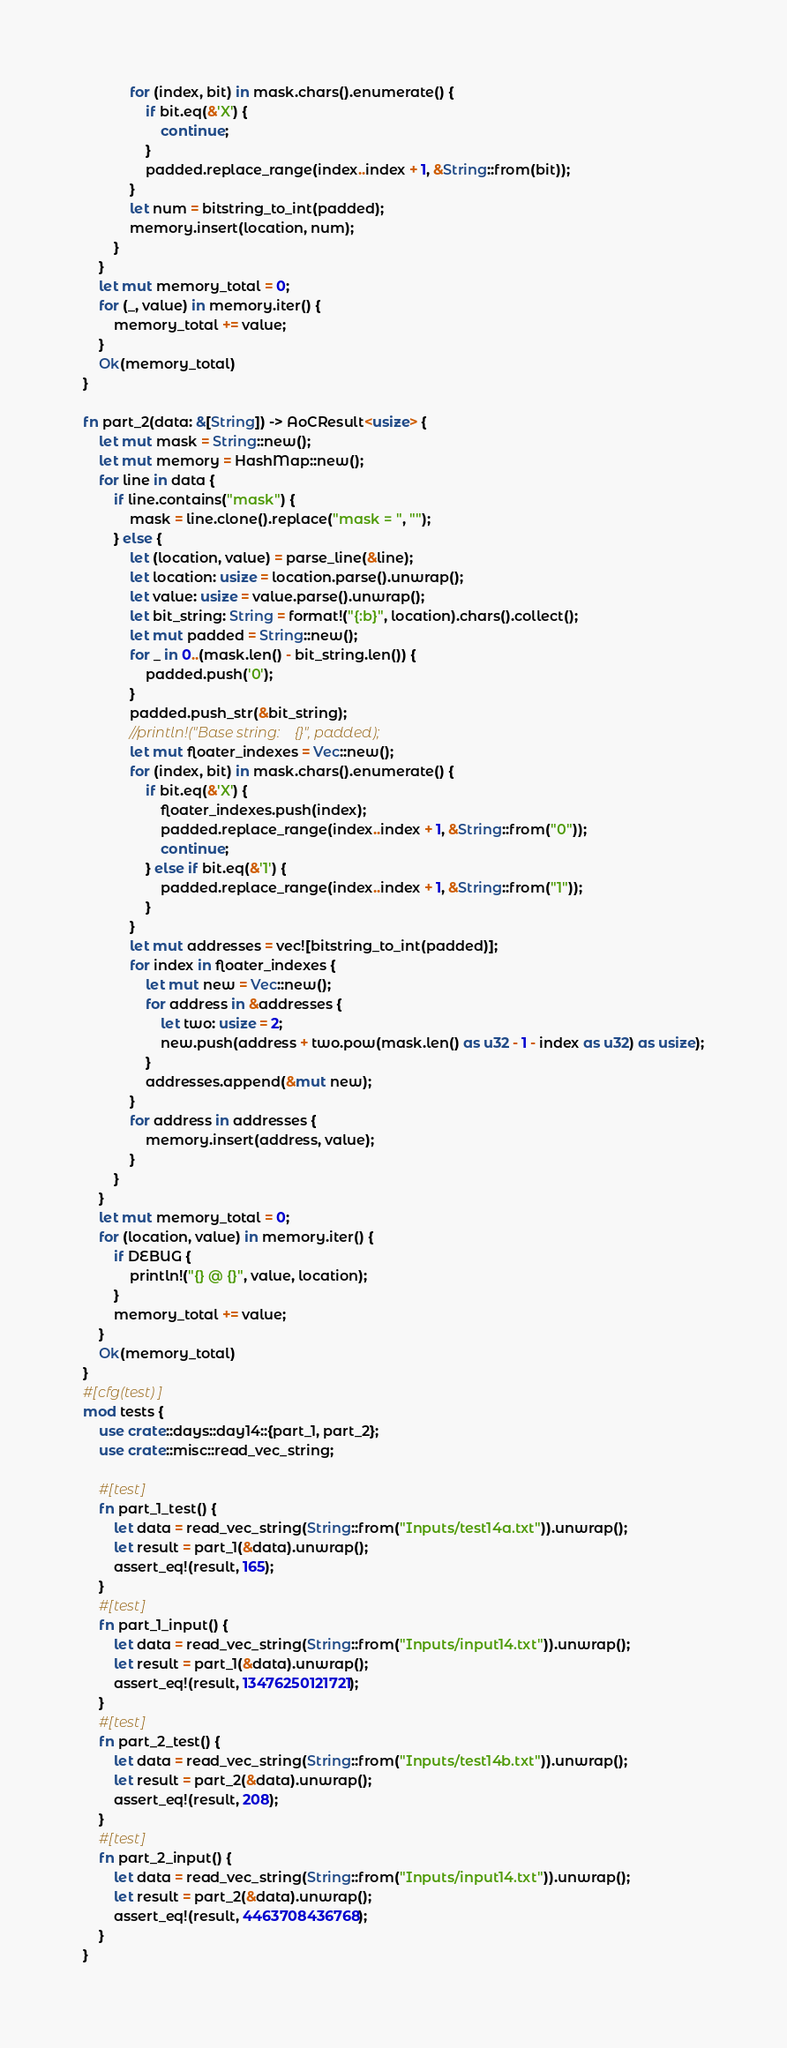<code> <loc_0><loc_0><loc_500><loc_500><_Rust_>            for (index, bit) in mask.chars().enumerate() {
                if bit.eq(&'X') {
                    continue;
                }
                padded.replace_range(index..index + 1, &String::from(bit));
            }
            let num = bitstring_to_int(padded);
            memory.insert(location, num);
        }
    }
    let mut memory_total = 0;
    for (_, value) in memory.iter() {
        memory_total += value;
    }
    Ok(memory_total)
}

fn part_2(data: &[String]) -> AoCResult<usize> {
    let mut mask = String::new();
    let mut memory = HashMap::new();
    for line in data {
        if line.contains("mask") {
            mask = line.clone().replace("mask = ", "");
        } else {
            let (location, value) = parse_line(&line);
            let location: usize = location.parse().unwrap();
            let value: usize = value.parse().unwrap();
            let bit_string: String = format!("{:b}", location).chars().collect();
            let mut padded = String::new();
            for _ in 0..(mask.len() - bit_string.len()) {
                padded.push('0');
            }
            padded.push_str(&bit_string);
            //println!("Base string:    {}", padded);
            let mut floater_indexes = Vec::new();
            for (index, bit) in mask.chars().enumerate() {
                if bit.eq(&'X') {
                    floater_indexes.push(index);
                    padded.replace_range(index..index + 1, &String::from("0"));
                    continue;
                } else if bit.eq(&'1') {
                    padded.replace_range(index..index + 1, &String::from("1"));
                }
            }
            let mut addresses = vec![bitstring_to_int(padded)];
            for index in floater_indexes {
                let mut new = Vec::new();
                for address in &addresses {
                    let two: usize = 2;
                    new.push(address + two.pow(mask.len() as u32 - 1 - index as u32) as usize);
                }
                addresses.append(&mut new);
            }
            for address in addresses {
                memory.insert(address, value);
            }
        }
    }
    let mut memory_total = 0;
    for (location, value) in memory.iter() {
        if DEBUG {
            println!("{} @ {}", value, location);
        }
        memory_total += value;
    }
    Ok(memory_total)
}
#[cfg(test)]
mod tests {
    use crate::days::day14::{part_1, part_2};
    use crate::misc::read_vec_string;

    #[test]
    fn part_1_test() {
        let data = read_vec_string(String::from("Inputs/test14a.txt")).unwrap();
        let result = part_1(&data).unwrap();
        assert_eq!(result, 165);
    }
    #[test]
    fn part_1_input() {
        let data = read_vec_string(String::from("Inputs/input14.txt")).unwrap();
        let result = part_1(&data).unwrap();
        assert_eq!(result, 13476250121721);
    }
    #[test]
    fn part_2_test() {
        let data = read_vec_string(String::from("Inputs/test14b.txt")).unwrap();
        let result = part_2(&data).unwrap();
        assert_eq!(result, 208);
    }
    #[test]
    fn part_2_input() {
        let data = read_vec_string(String::from("Inputs/input14.txt")).unwrap();
        let result = part_2(&data).unwrap();
        assert_eq!(result, 4463708436768);
    }
}
</code> 